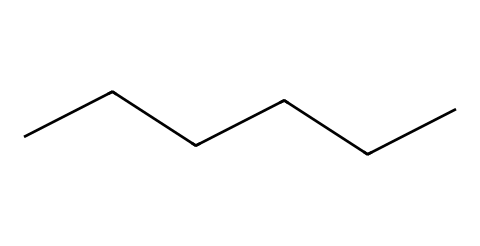What is the molecular formula of hexane? The SMILES representation "CCCCCC" indicates a straight-chain alkane with six carbon atoms. In organic chemistry, the molecular formula is determined by counting the number of carbon (C) and hydrogen (H) atoms. Hexane, having six carbon atoms, will have twelve hydrogen atoms, resulting in the formula C6H14.
Answer: C6H14 How many carbon atoms are in hexane? By analyzing the SMILES notation "CCCCCC," it can be seen that it contains six 'C' characters, representing six carbon atoms in the molecule.
Answer: six What is the type of bonding in hexane? Hexane consists of a chain of carbon atoms connected by single covalent bonds, as indicated by the linear structure of the SMILES. The lack of double or triple bonds points to it being a saturated hydrocarbon, where every carbon atom forms four bonds (either to other carbon atoms or hydrogen).
Answer: single covalent What is the state of hexane at room temperature? Hexane is a straight-chain alkane with relatively low molecular weight, indicated by six carbon atoms. At room temperature (around 20-25 degrees Celsius), hexane is typically a liquid due to its molecular structure and presence of only single bonds which allows it to remain fluid.
Answer: liquid Is hexane polar or nonpolar? The structure of hexane, which is symmetric with all carbon and hydrogen atoms, results in a molecule that does not have distinct positive and negative poles. Therefore, hexane is classified as a nonpolar solvent.
Answer: nonpolar What is the primary use of hexane? Given its properties as a solvent and its ability to dissolve certain compounds, hexane is notably used in the production of glues and adhesives for office supplies. This is directly related to its low volatility and effectiveness as a solvent.
Answer: glues and adhesives 